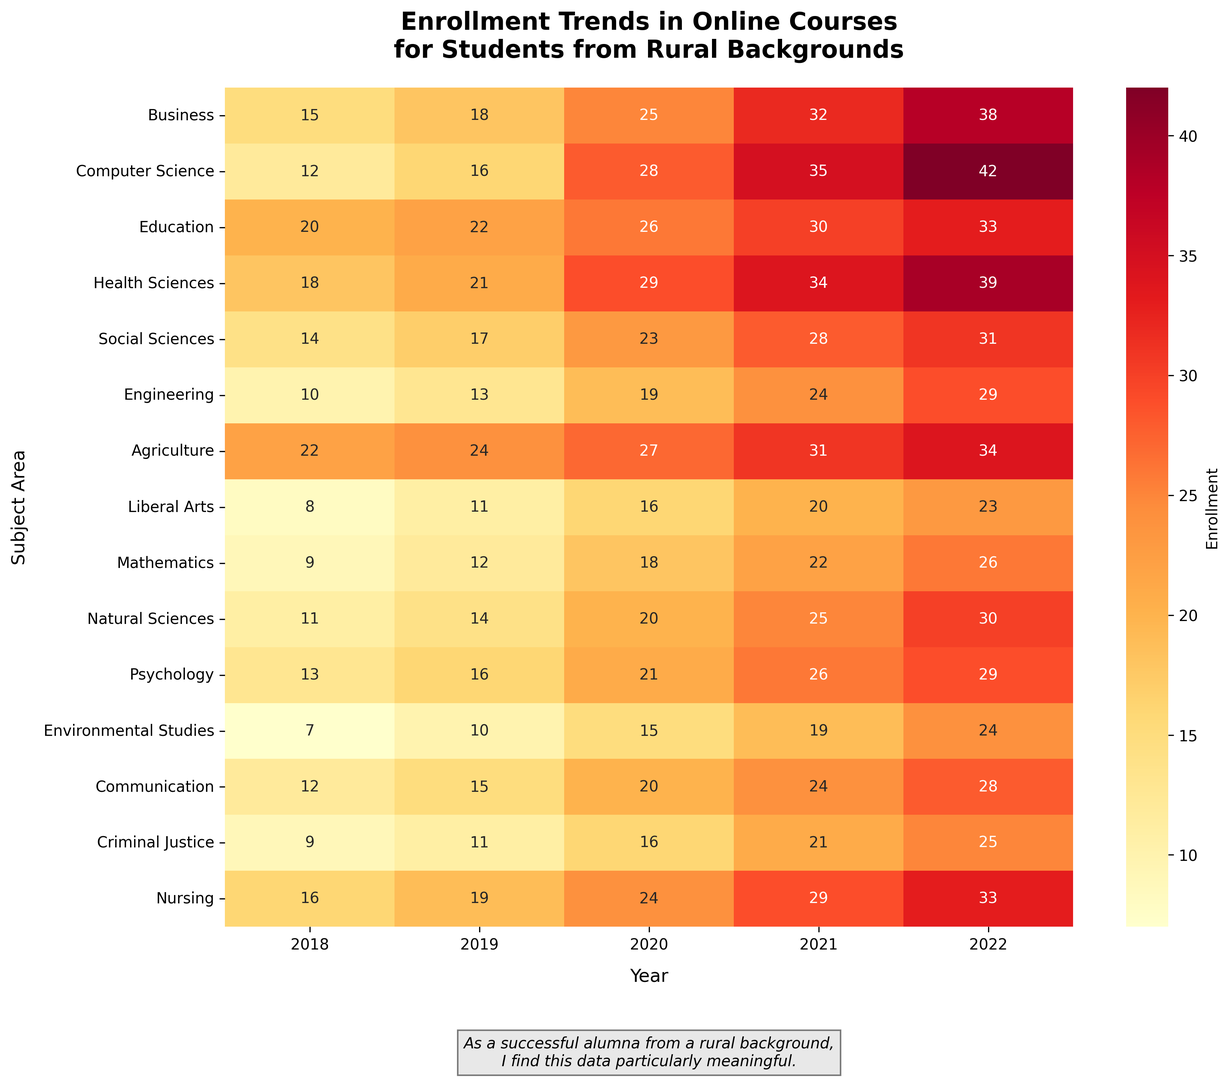How did the enrollment in Business courses change from 2018 to 2022? First, locate the row corresponding to "Business". Note that the enrollment in 2018 was 15 and in 2022 it was 38. The change can be calculated by subtracting the initial value (2018) from the final value (2022): 38 - 15 = 23
Answer: Increased by 23 Which subject area had the highest enrollment in 2022? Find the column for 2022 and look for the maximum value. The highest enrollment in 2022 is 42, which corresponds to "Computer Science".
Answer: Computer Science Compare the enrollment trend for Nursing and Education from 2018 to 2022. Which had a steeper increase? Compare the rows for "Nursing" and "Education". Enrollment in Nursing went from 16 to 33 (a difference of 17), while Education went from 20 to 33 (a difference of 13). The increase in Nursing (17) is greater than in Education (13).
Answer: Nursing What's the average enrollment in Mathematics over the years? Locate the row for "Mathematics" and add the values for each year: 9, 12, 18, 22, 26. The sum is 87. Divide by the number of years (5): 87 / 5 = 17.4
Answer: 17.4 Which subject area showed the smallest increase in enrollment from 2018 to 2022? Calculate the increase for each subject by subtracting the 2018 value from the 2022 value. The smallest increase is found for "Liberal Arts", which increased from 8 to 23, a difference of 15.
Answer: Liberal Arts What is the combined enrollment for Computer Science and Social Sciences in 2021? Find the corresponding values in 2021 for both subjects. Computer Science had 35 and Social Sciences had 28. The combined total is 35 + 28 = 63
Answer: 63 By how much did the enrollment in Environmental Studies increase between 2019 and 2022? Locate the row for "Environmental Studies" and compare the values for 2019 and 2022. Enrollment increased from 10 to 24. The difference is 24 - 10 = 14
Answer: Increased by 14 Which subjects had more than 30 students enrolled by 2021 but not in 2020? Review the enrollment values for 2020 and 2021 across all subjects. "Education" and "Social Sciences" both had enrollment under 30 in 2020 but reached or exceeded 30 by 2021.
Answer: Education, Social Sciences 